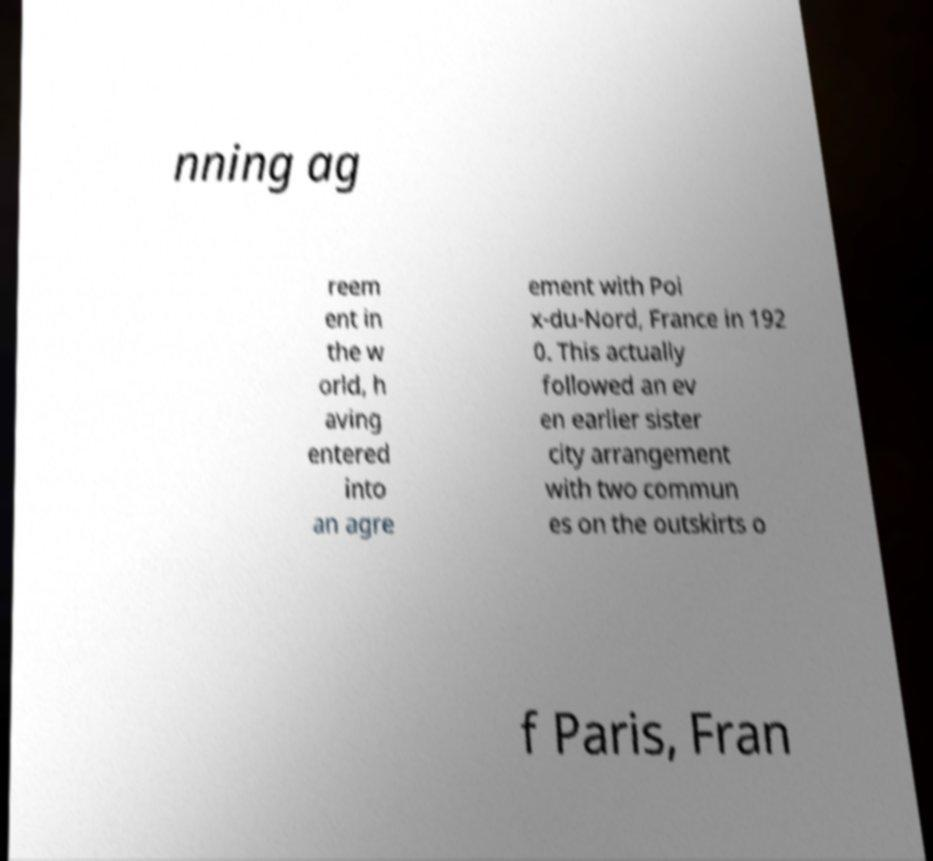Can you accurately transcribe the text from the provided image for me? nning ag reem ent in the w orld, h aving entered into an agre ement with Poi x-du-Nord, France in 192 0. This actually followed an ev en earlier sister city arrangement with two commun es on the outskirts o f Paris, Fran 